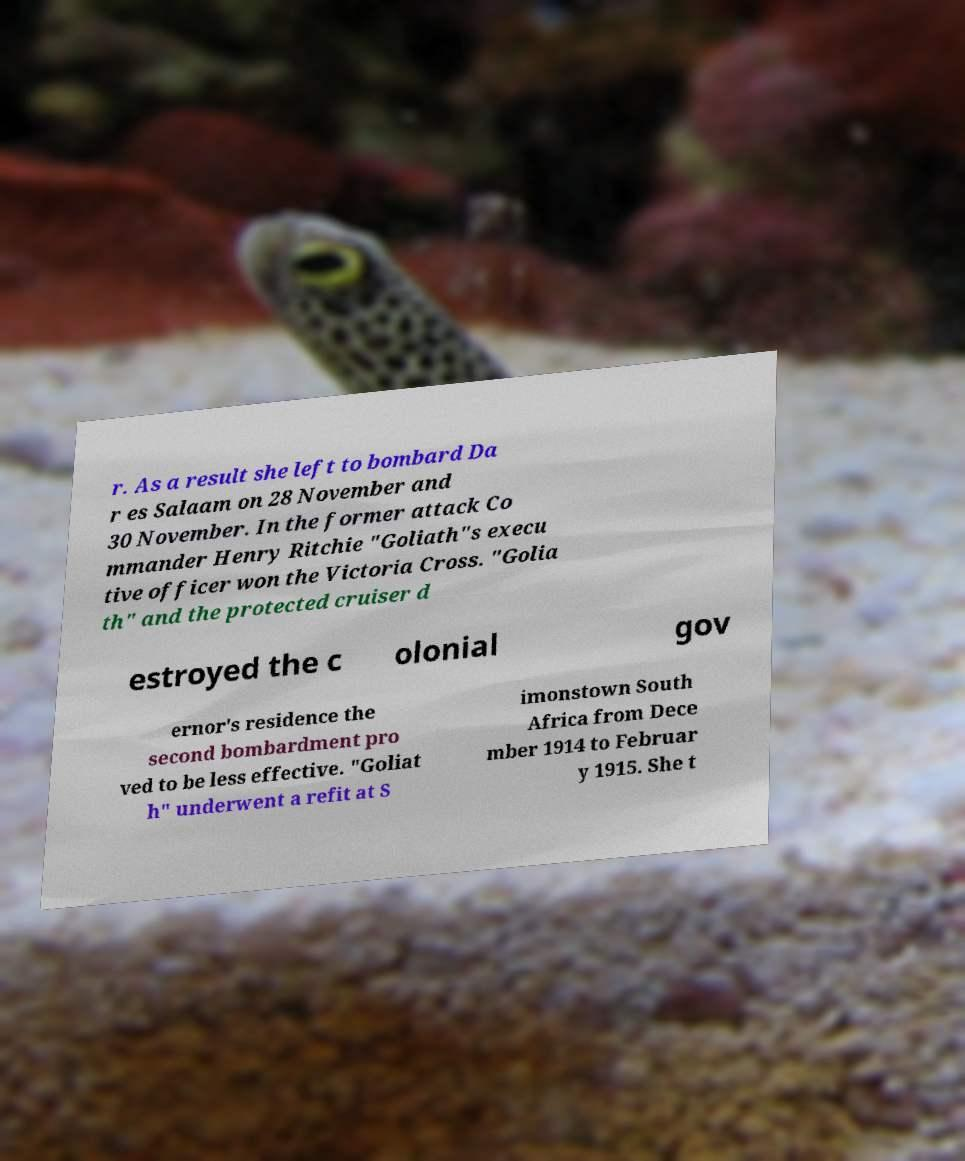Could you assist in decoding the text presented in this image and type it out clearly? r. As a result she left to bombard Da r es Salaam on 28 November and 30 November. In the former attack Co mmander Henry Ritchie "Goliath"s execu tive officer won the Victoria Cross. "Golia th" and the protected cruiser d estroyed the c olonial gov ernor's residence the second bombardment pro ved to be less effective. "Goliat h" underwent a refit at S imonstown South Africa from Dece mber 1914 to Februar y 1915. She t 